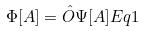<formula> <loc_0><loc_0><loc_500><loc_500>\Phi [ A ] = \hat { O } \Psi [ A ] E q 1</formula> 